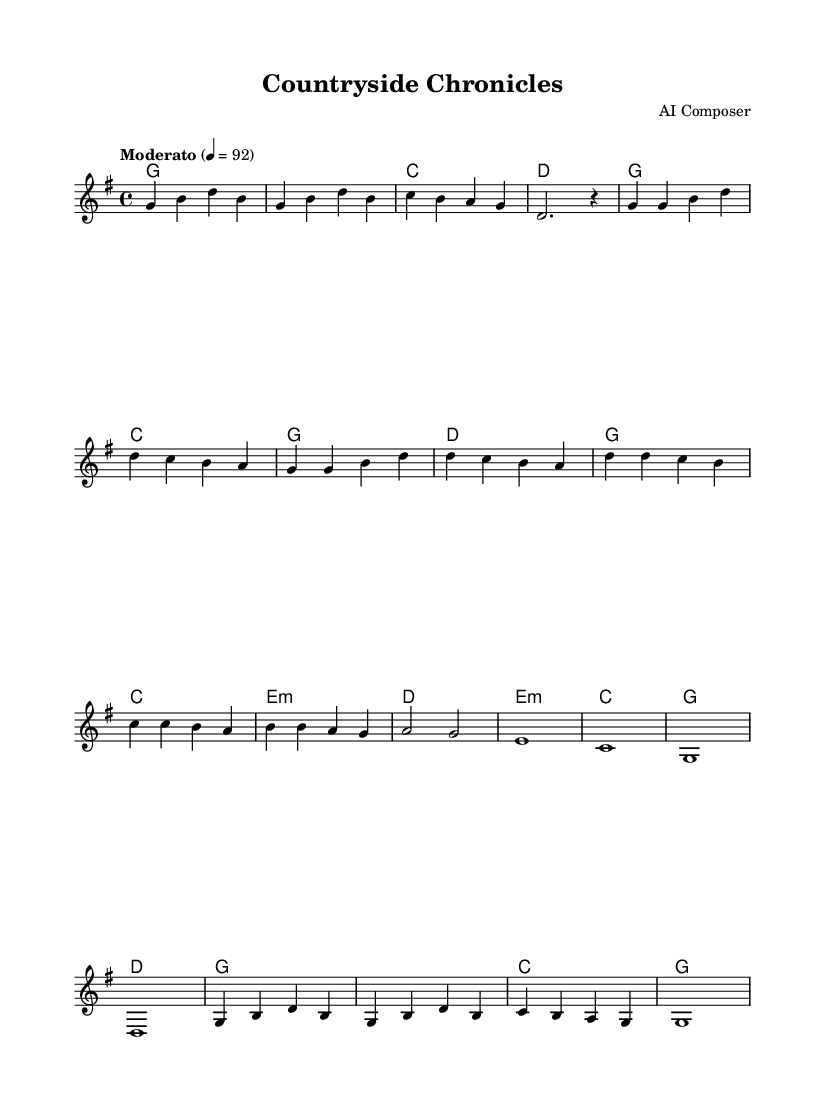What is the key signature of this music? The key signature is G major, which has one sharp, F#. This can be determined by looking at the key signature indicated in the global section of the music.
Answer: G major What is the time signature of this piece? The time signature is 4/4, which can be found in the global section of the music. It denotes that there are four beats per measure and a quarter note receives one beat.
Answer: 4/4 What is the tempo marking for this piece? The tempo marking is "Moderato" at 92 beats per minute. This is specified in the global settings of the sheet music.
Answer: Moderato 92 How many distinct sections can be identified in this piece? There are five distinct sections: Intro, Verse, Chorus, Bridge, and Outro. By analyzing the labels and structure of the music, each section's purpose can be inferred.
Answer: Five What chord follows the melody's first note? The first note of the melody is G, and it is accompanied by a G major chord. This can be seen in the harmonies section where the first chord is written as G.
Answer: G Which section features a major chord followed by a minor chord? The Chorus section features a major chord (C) followed by a minor chord (E minor). This can be deduced from the chord changes written under the Chorus part of the music.
Answer: Chorus What type of musical forms are utilized in this piece? The piece employs a simple verse-chorus form, where the verse is repeated in a similar way and contrasts with the chorus, providing a clear structure. This is discerned by observing the repetition and variation of sections throughout the music.
Answer: Verse-chorus 